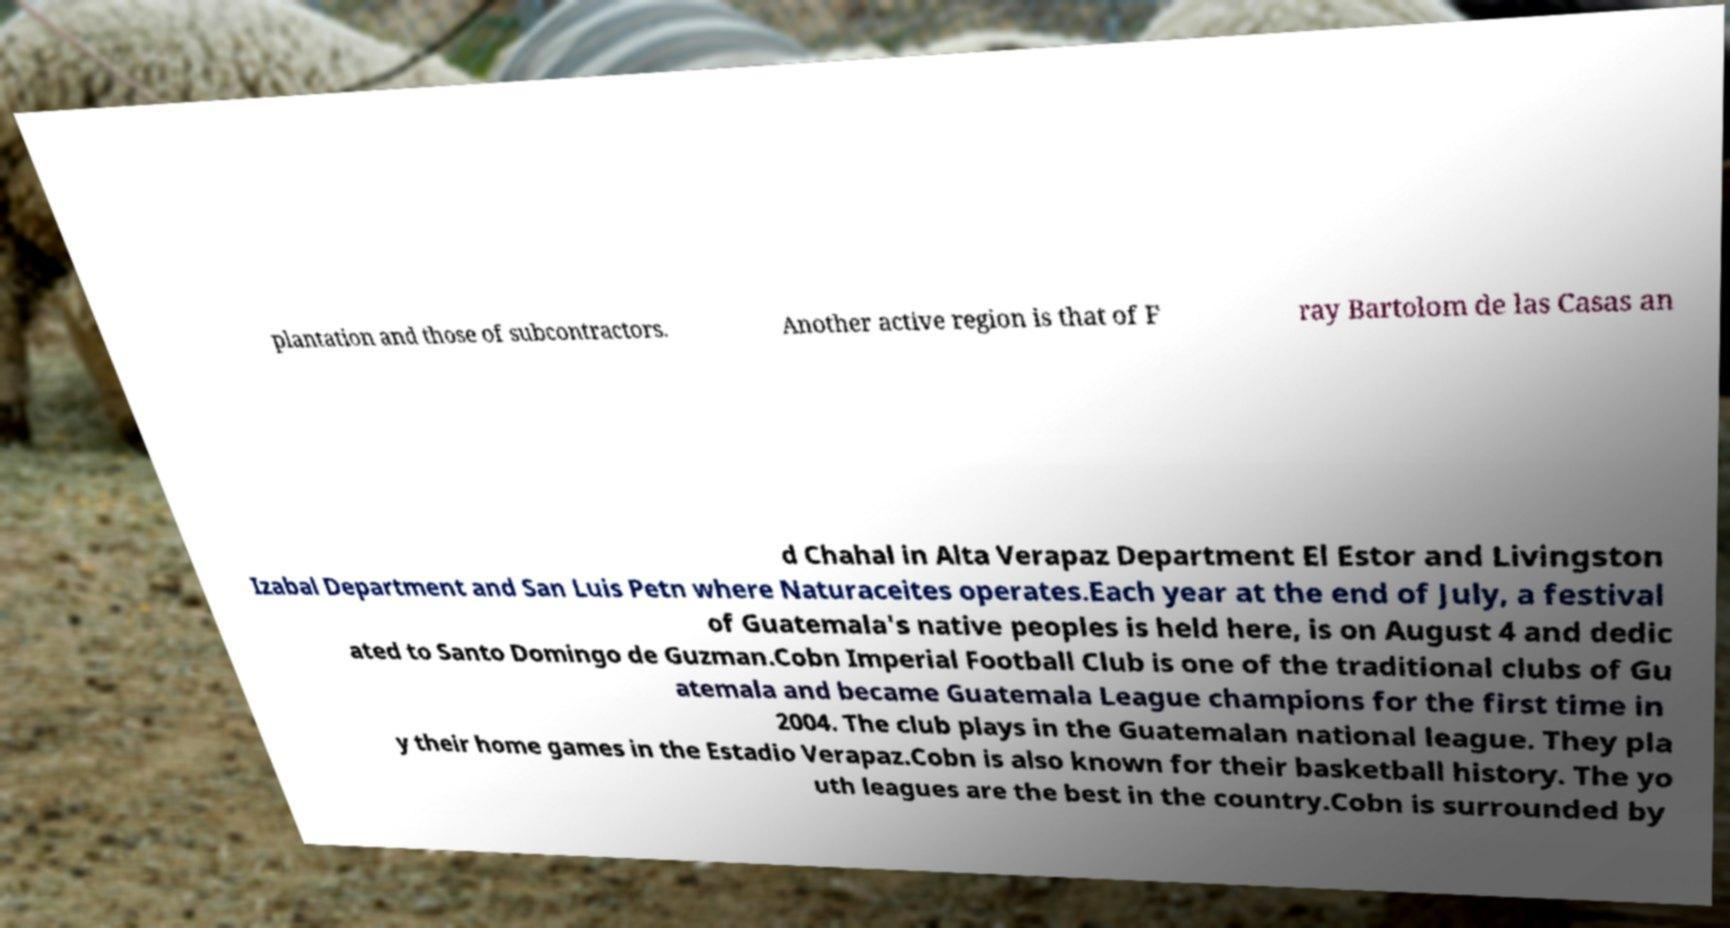Can you accurately transcribe the text from the provided image for me? plantation and those of subcontractors. Another active region is that of F ray Bartolom de las Casas an d Chahal in Alta Verapaz Department El Estor and Livingston Izabal Department and San Luis Petn where Naturaceites operates.Each year at the end of July, a festival of Guatemala's native peoples is held here, is on August 4 and dedic ated to Santo Domingo de Guzman.Cobn Imperial Football Club is one of the traditional clubs of Gu atemala and became Guatemala League champions for the first time in 2004. The club plays in the Guatemalan national league. They pla y their home games in the Estadio Verapaz.Cobn is also known for their basketball history. The yo uth leagues are the best in the country.Cobn is surrounded by 